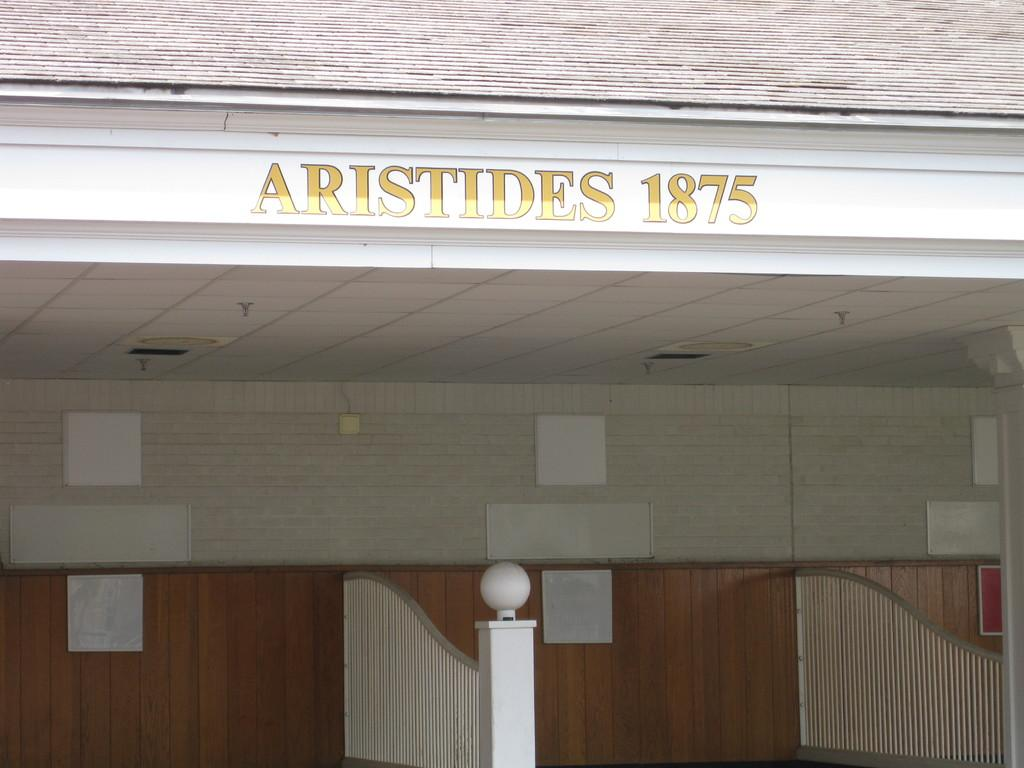What type of structure is present in the image? There is a building in the image. What can be seen attached to the wall of the building? Boards are attached to the wall of the building. Can you describe any other architectural features in the image? There is a pillar in the image. What type of illumination is present in the image? There is a light in the image. What is written or displayed at the top of the building? Alphabets and numbers are visible at the top of the building. Can you tell me how many flowers are planted in front of the building? There is no information about flowers in the image, so it is not possible to determine their presence or quantity. 